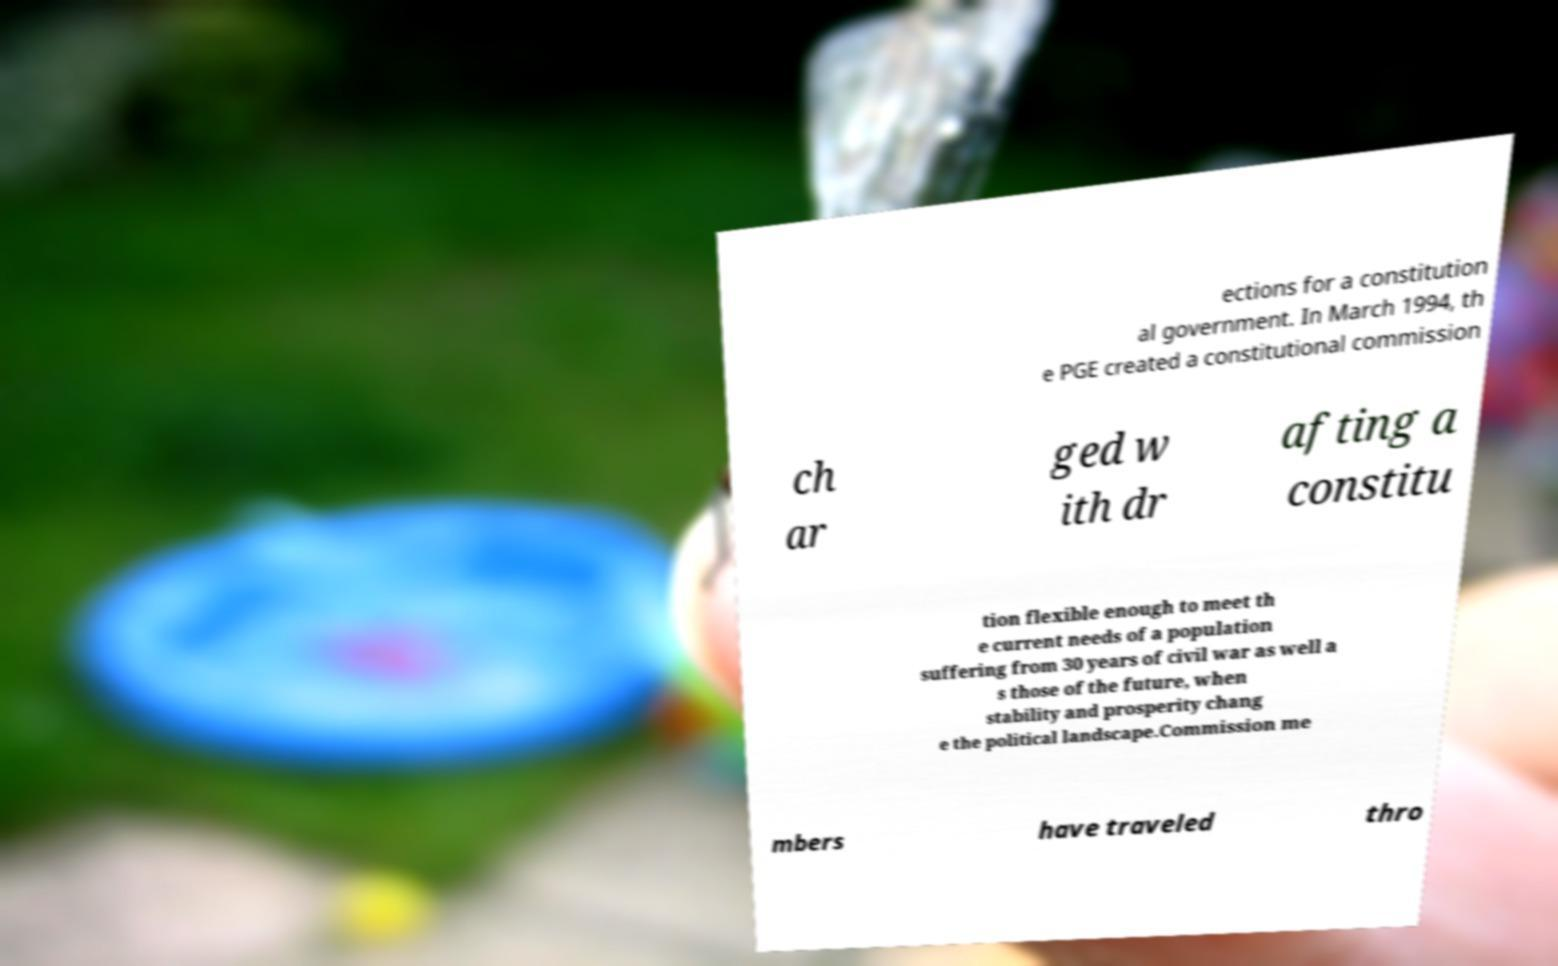Please identify and transcribe the text found in this image. ections for a constitution al government. In March 1994, th e PGE created a constitutional commission ch ar ged w ith dr afting a constitu tion flexible enough to meet th e current needs of a population suffering from 30 years of civil war as well a s those of the future, when stability and prosperity chang e the political landscape.Commission me mbers have traveled thro 